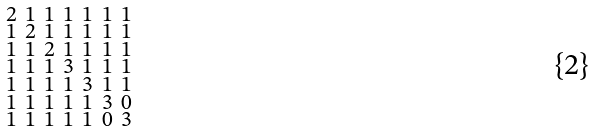Convert formula to latex. <formula><loc_0><loc_0><loc_500><loc_500>\begin{smallmatrix} 2 & 1 & 1 & 1 & 1 & 1 & 1 \\ 1 & 2 & 1 & 1 & 1 & 1 & 1 \\ 1 & 1 & 2 & 1 & 1 & 1 & 1 \\ 1 & 1 & 1 & 3 & 1 & 1 & 1 \\ 1 & 1 & 1 & 1 & 3 & 1 & 1 \\ 1 & 1 & 1 & 1 & 1 & 3 & 0 \\ 1 & 1 & 1 & 1 & 1 & 0 & 3 \end{smallmatrix}</formula> 